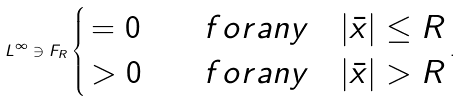Convert formula to latex. <formula><loc_0><loc_0><loc_500><loc_500>L ^ { \infty } \ni F _ { R } \begin{cases} \, = 0 & \quad f o r a n y \quad | \bar { x } | \leq R \\ \, > 0 & \quad f o r a n y \quad | \bar { x } | > R \end{cases} .</formula> 